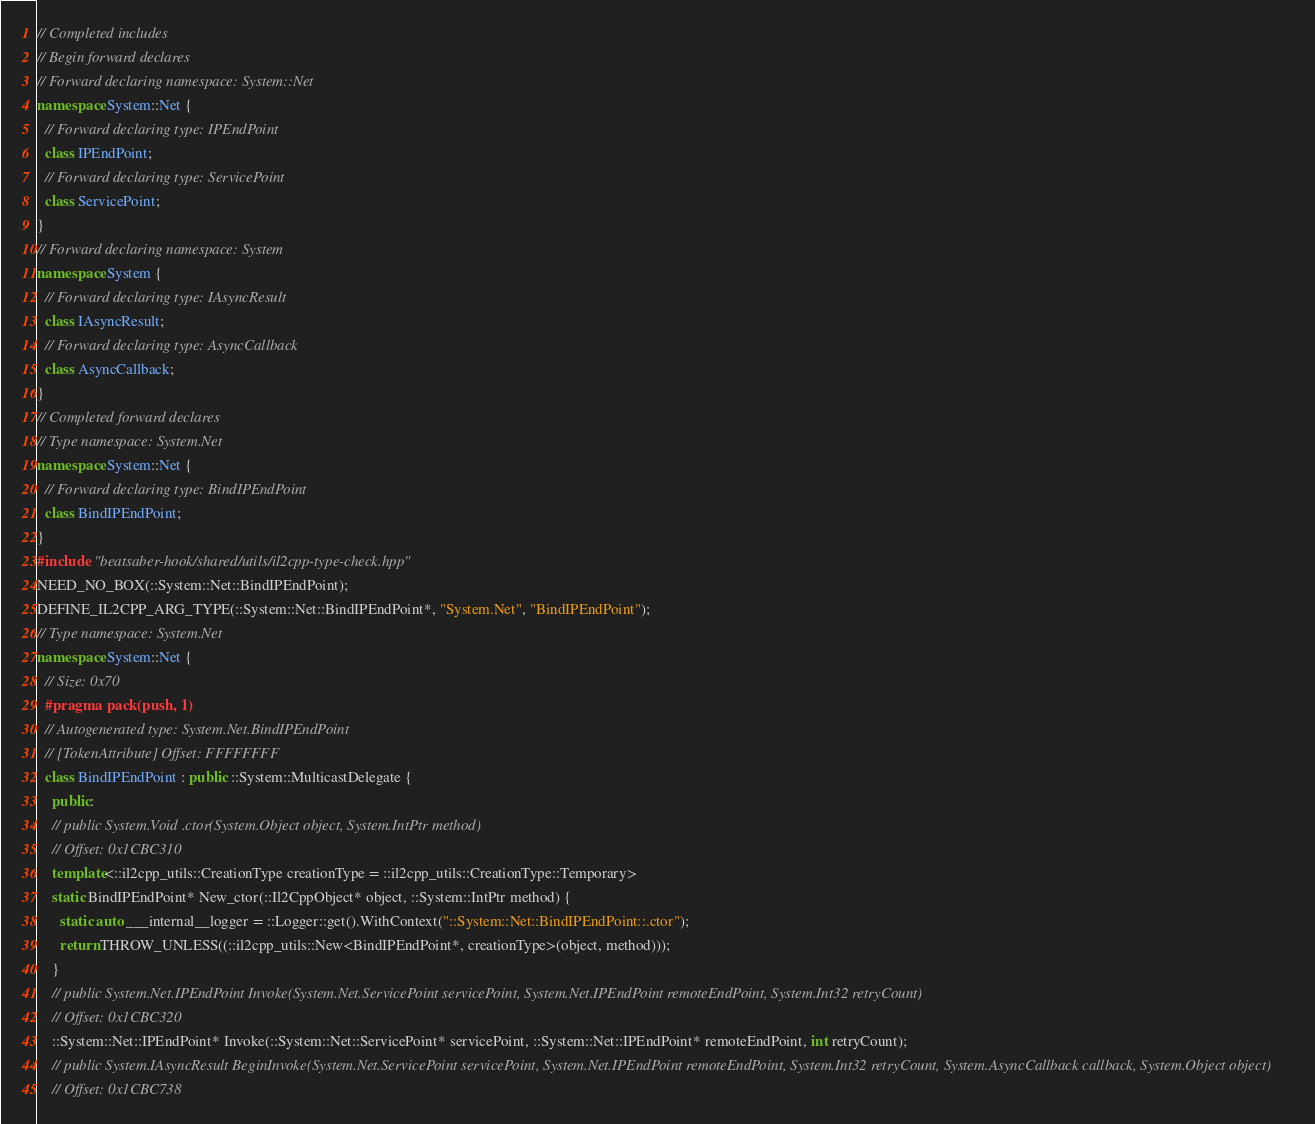Convert code to text. <code><loc_0><loc_0><loc_500><loc_500><_C++_>// Completed includes
// Begin forward declares
// Forward declaring namespace: System::Net
namespace System::Net {
  // Forward declaring type: IPEndPoint
  class IPEndPoint;
  // Forward declaring type: ServicePoint
  class ServicePoint;
}
// Forward declaring namespace: System
namespace System {
  // Forward declaring type: IAsyncResult
  class IAsyncResult;
  // Forward declaring type: AsyncCallback
  class AsyncCallback;
}
// Completed forward declares
// Type namespace: System.Net
namespace System::Net {
  // Forward declaring type: BindIPEndPoint
  class BindIPEndPoint;
}
#include "beatsaber-hook/shared/utils/il2cpp-type-check.hpp"
NEED_NO_BOX(::System::Net::BindIPEndPoint);
DEFINE_IL2CPP_ARG_TYPE(::System::Net::BindIPEndPoint*, "System.Net", "BindIPEndPoint");
// Type namespace: System.Net
namespace System::Net {
  // Size: 0x70
  #pragma pack(push, 1)
  // Autogenerated type: System.Net.BindIPEndPoint
  // [TokenAttribute] Offset: FFFFFFFF
  class BindIPEndPoint : public ::System::MulticastDelegate {
    public:
    // public System.Void .ctor(System.Object object, System.IntPtr method)
    // Offset: 0x1CBC310
    template<::il2cpp_utils::CreationType creationType = ::il2cpp_utils::CreationType::Temporary>
    static BindIPEndPoint* New_ctor(::Il2CppObject* object, ::System::IntPtr method) {
      static auto ___internal__logger = ::Logger::get().WithContext("::System::Net::BindIPEndPoint::.ctor");
      return THROW_UNLESS((::il2cpp_utils::New<BindIPEndPoint*, creationType>(object, method)));
    }
    // public System.Net.IPEndPoint Invoke(System.Net.ServicePoint servicePoint, System.Net.IPEndPoint remoteEndPoint, System.Int32 retryCount)
    // Offset: 0x1CBC320
    ::System::Net::IPEndPoint* Invoke(::System::Net::ServicePoint* servicePoint, ::System::Net::IPEndPoint* remoteEndPoint, int retryCount);
    // public System.IAsyncResult BeginInvoke(System.Net.ServicePoint servicePoint, System.Net.IPEndPoint remoteEndPoint, System.Int32 retryCount, System.AsyncCallback callback, System.Object object)
    // Offset: 0x1CBC738</code> 